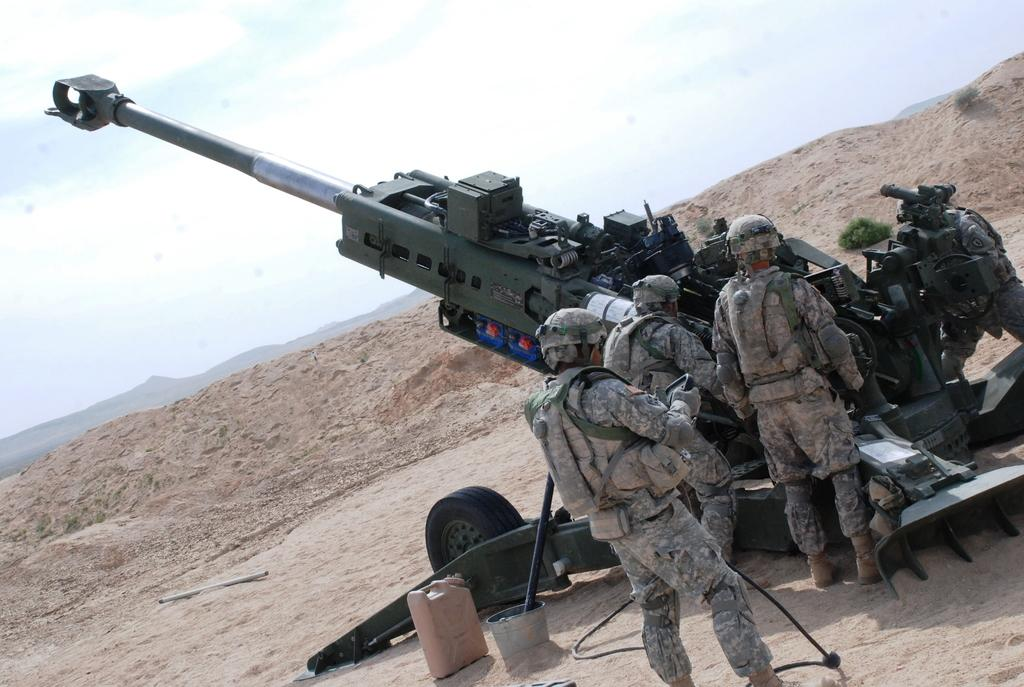Who or what can be seen in the image? There are people in the image. What object is present in the image that is not a person? There is a missile in the image. Where is the missile located? The missile is on a rock in the image. What type of natural landscape is visible in the image? There are mountains visible in the image. What type of hope can be seen in the image? There is no reference to hope in the image; it features people and a missile on a rock with mountains in the background. 